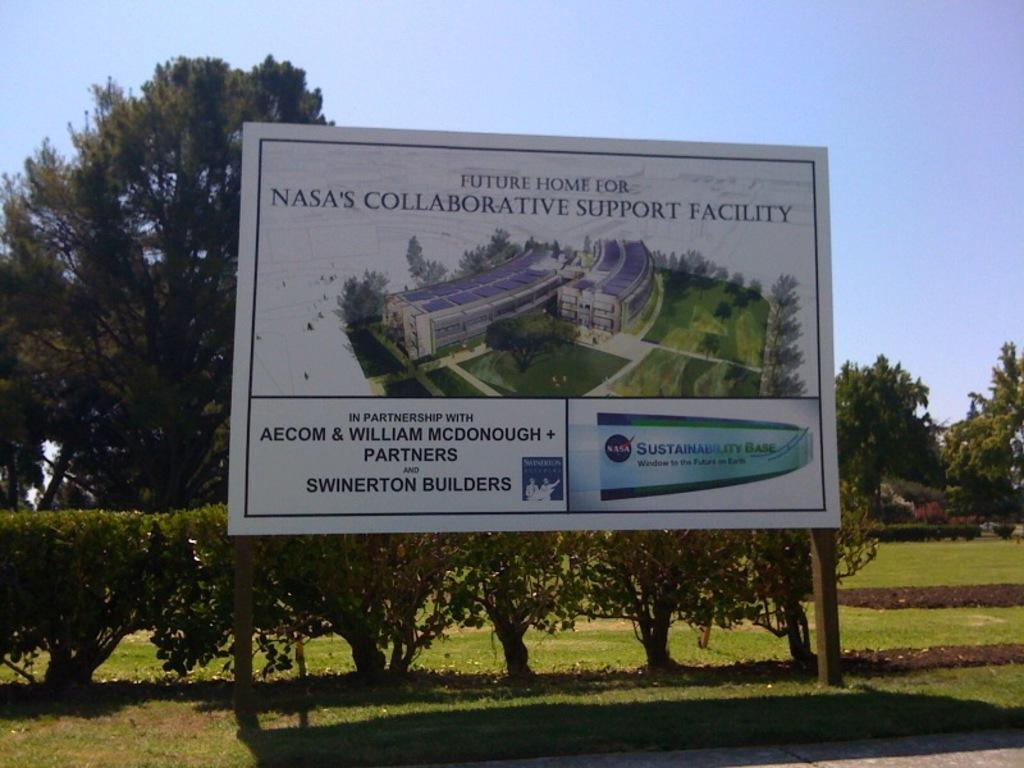<image>
Render a clear and concise summary of the photo. A green grassy area has a rendering of NASA's Collaborative Support Facility new home. 